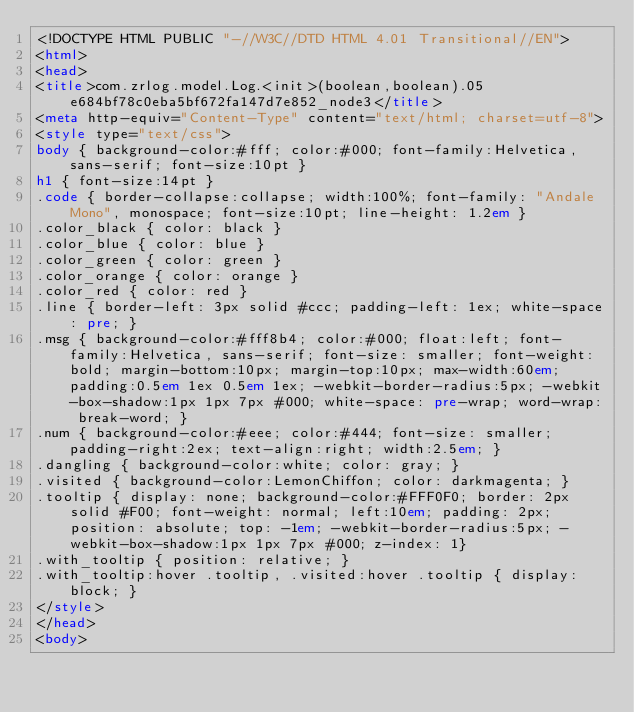<code> <loc_0><loc_0><loc_500><loc_500><_HTML_><!DOCTYPE HTML PUBLIC "-//W3C//DTD HTML 4.01 Transitional//EN">
<html>
<head>
<title>com.zrlog.model.Log.<init>(boolean,boolean).05e684bf78c0eba5bf672fa147d7e852_node3</title>
<meta http-equiv="Content-Type" content="text/html; charset=utf-8">
<style type="text/css">
body { background-color:#fff; color:#000; font-family:Helvetica, sans-serif; font-size:10pt }
h1 { font-size:14pt }
.code { border-collapse:collapse; width:100%; font-family: "Andale Mono", monospace; font-size:10pt; line-height: 1.2em }
.color_black { color: black }
.color_blue { color: blue }
.color_green { color: green }
.color_orange { color: orange }
.color_red { color: red }
.line { border-left: 3px solid #ccc; padding-left: 1ex; white-space: pre; }
.msg { background-color:#fff8b4; color:#000; float:left; font-family:Helvetica, sans-serif; font-size: smaller; font-weight: bold; margin-bottom:10px; margin-top:10px; max-width:60em; padding:0.5em 1ex 0.5em 1ex; -webkit-border-radius:5px; -webkit-box-shadow:1px 1px 7px #000; white-space: pre-wrap; word-wrap: break-word; }
.num { background-color:#eee; color:#444; font-size: smaller; padding-right:2ex; text-align:right; width:2.5em; }
.dangling { background-color:white; color: gray; }
.visited { background-color:LemonChiffon; color: darkmagenta; }
.tooltip { display: none; background-color:#FFF0F0; border: 2px solid #F00; font-weight: normal; left:10em; padding: 2px; position: absolute; top: -1em; -webkit-border-radius:5px; -webkit-box-shadow:1px 1px 7px #000; z-index: 1}
.with_tooltip { position: relative; }
.with_tooltip:hover .tooltip, .visited:hover .tooltip { display: block; }
</style>
</head>
<body></code> 